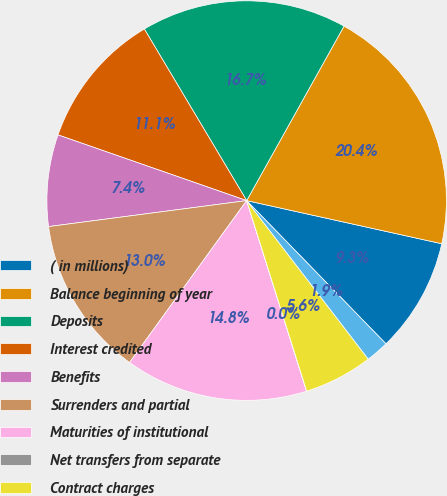<chart> <loc_0><loc_0><loc_500><loc_500><pie_chart><fcel>( in millions)<fcel>Balance beginning of year<fcel>Deposits<fcel>Interest credited<fcel>Benefits<fcel>Surrenders and partial<fcel>Maturities of institutional<fcel>Net transfers from separate<fcel>Contract charges<fcel>Fair value hedge adjustments<nl><fcel>9.26%<fcel>20.36%<fcel>16.66%<fcel>11.11%<fcel>7.41%<fcel>12.96%<fcel>14.81%<fcel>0.01%<fcel>5.56%<fcel>1.86%<nl></chart> 